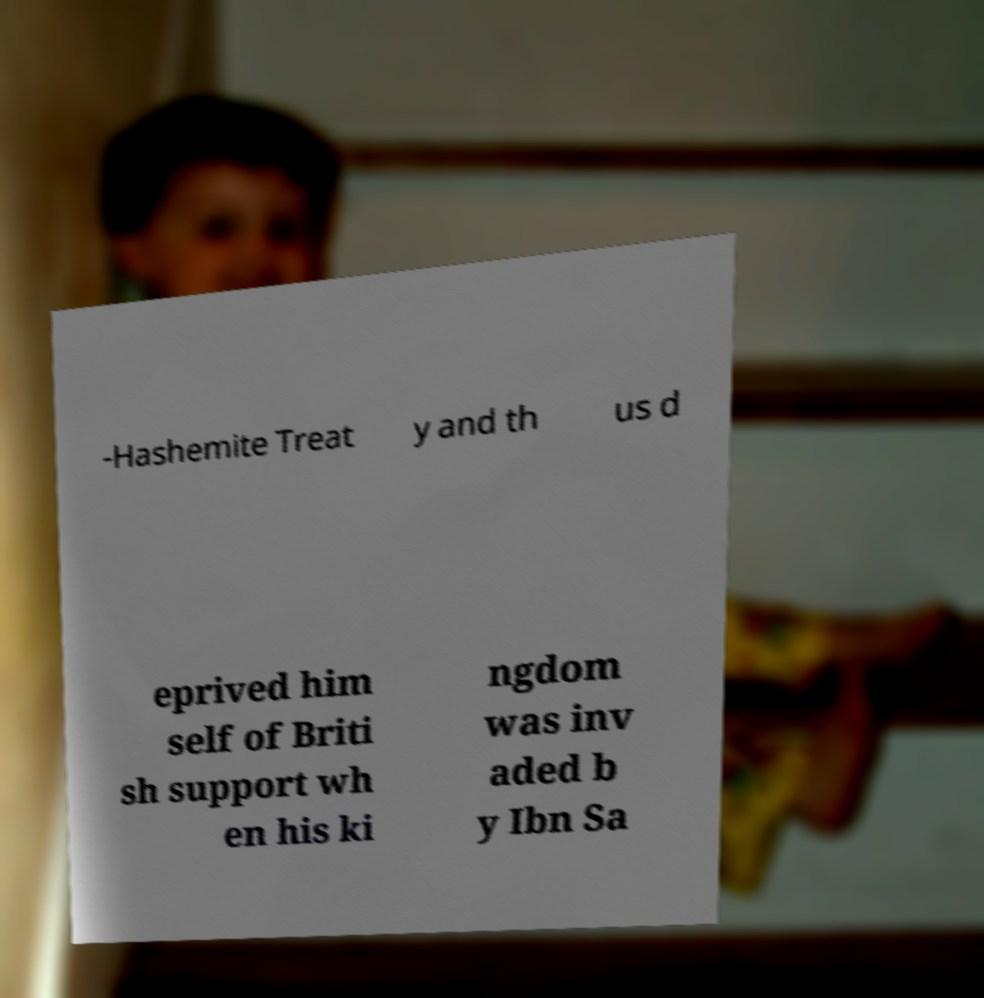Can you accurately transcribe the text from the provided image for me? -Hashemite Treat y and th us d eprived him self of Briti sh support wh en his ki ngdom was inv aded b y Ibn Sa 